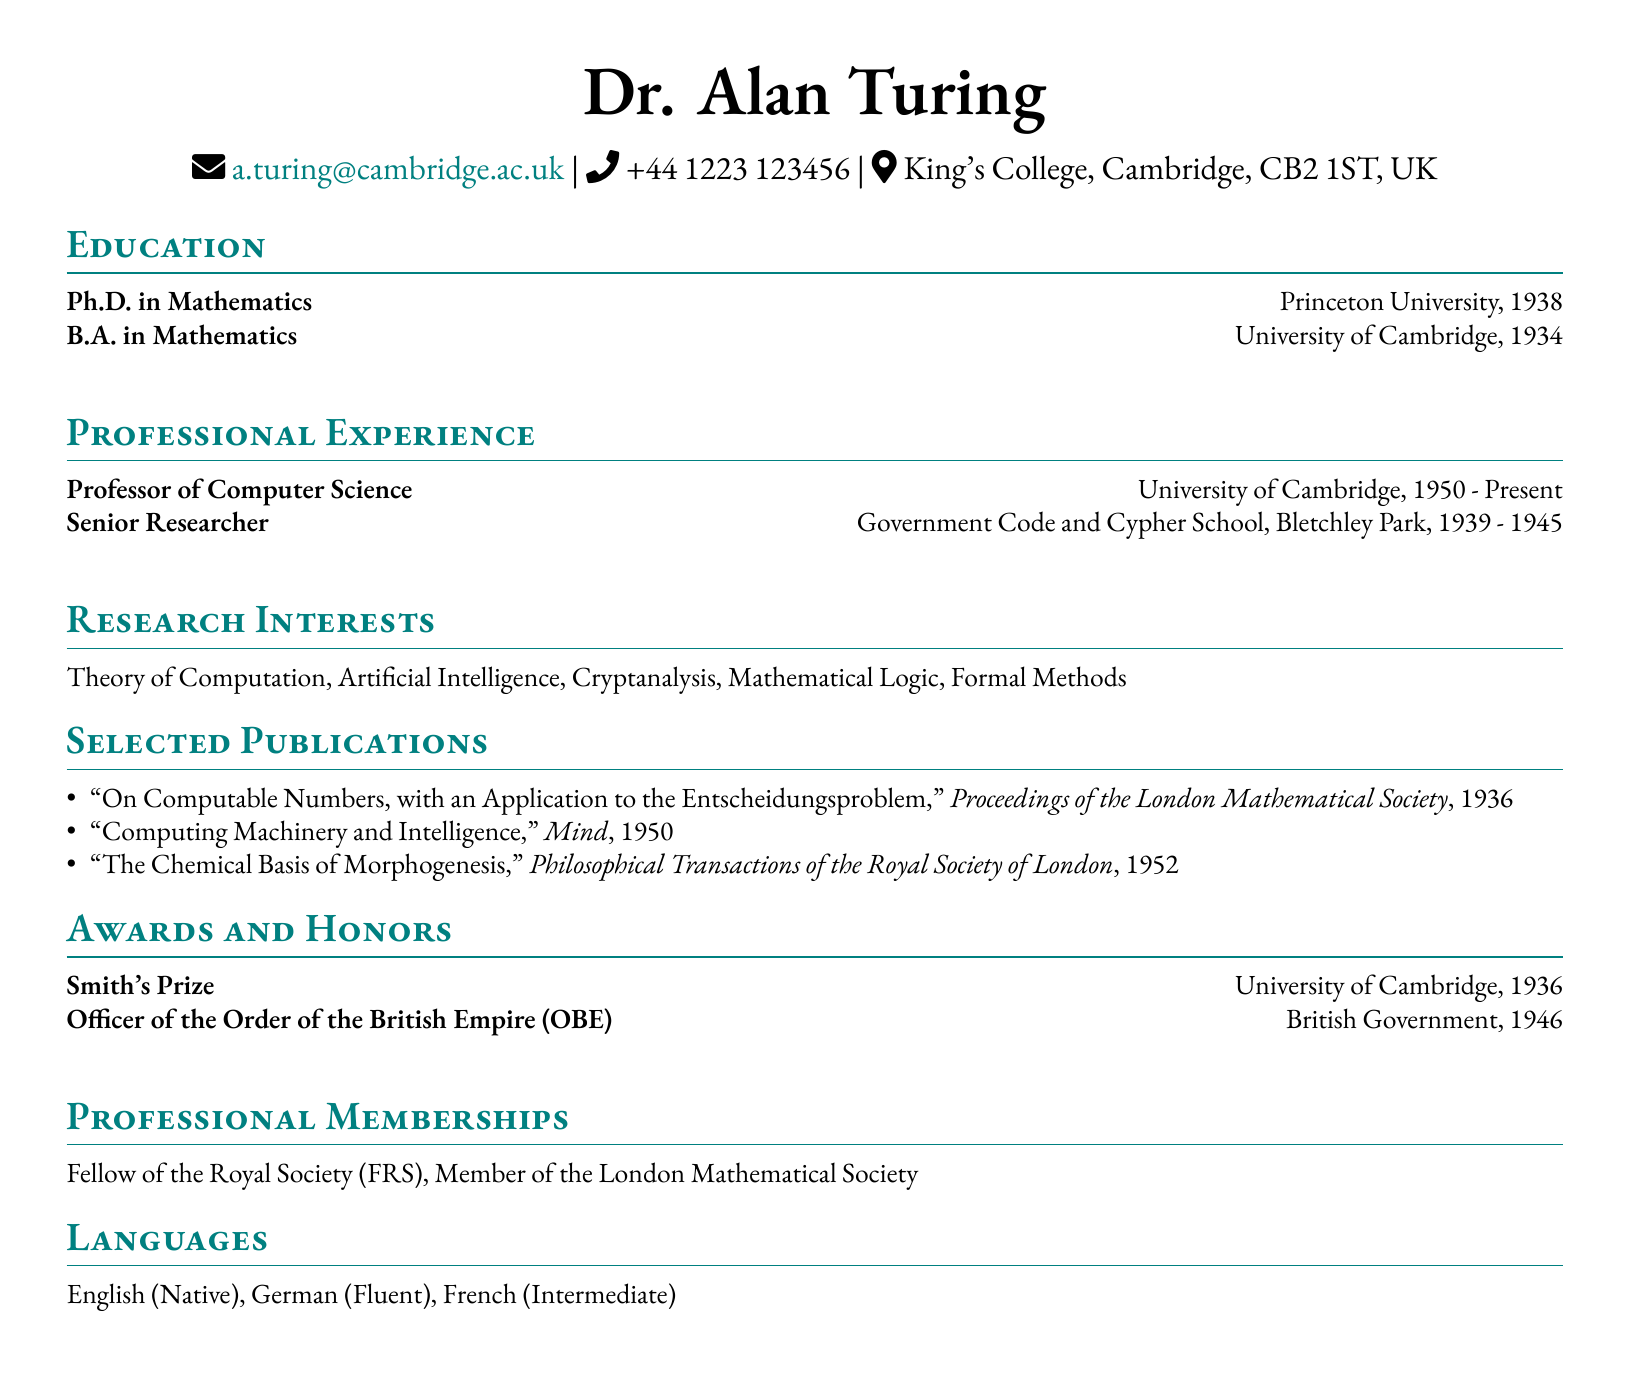What is the name of the person? The name is listed at the top of the document as "Dr. Alan Turing."
Answer: Dr. Alan Turing What year did Dr. Turing obtain his Ph.D.? The document states the year of his Ph.D. degree under the education section.
Answer: 1938 What is Dr. Turing’s current position? The document lists his current professional position in the professional experience section.
Answer: Professor of Computer Science Where did Dr. Turing work as a Senior Researcher? The professional experience section indicates his workplace during that time.
Answer: Government Code and Cypher School, Bletchley Park Which award did Dr. Turing receive in 1936? The awards section shows the name of the award he received that year.
Answer: Smith's Prize What is one of Dr. Turing's research interests? The research interests section provides a list from which one can be taken.
Answer: Theory of Computation How many languages is Dr. Turing proficient in? The languages section lists the languages he knows. The count can be derived from that section.
Answer: Three Which publication is authored by Dr. Turing from 1950? The selected publications section gives the title of the publication from that year.
Answer: Computing Machinery and Intelligence What institution did Dr. Turing attend for his undergraduate degree? The education section specifies the institution where he achieved his B.A.
Answer: University of Cambridge 